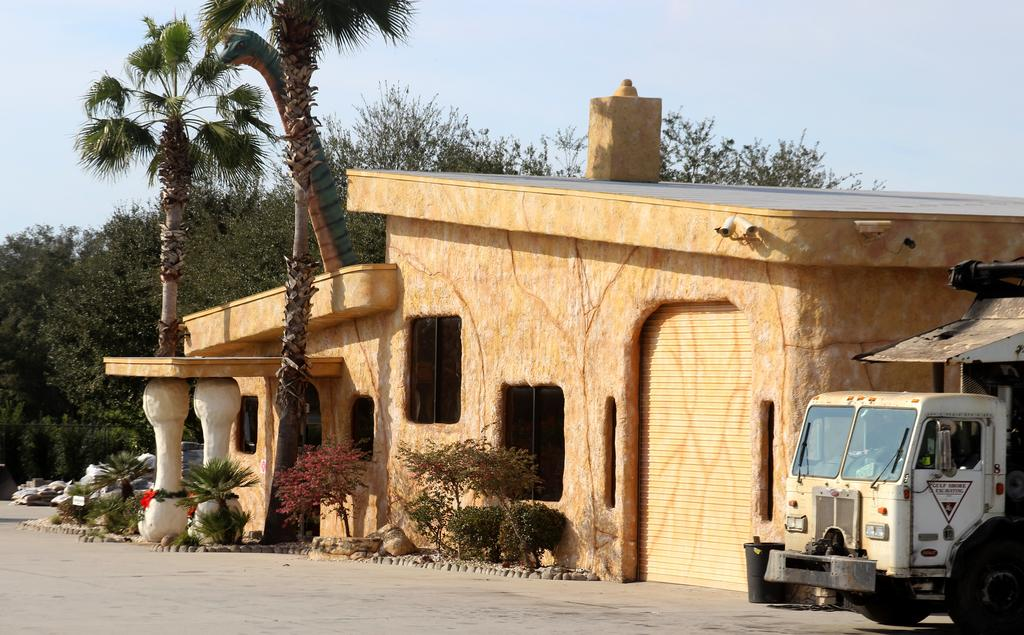What type of structure is depicted in the image? There is an architecture in the image. What is located beside the architecture? There is a vehicle beside the architecture. What type of vegetation is present around the architecture? There are plants and trees around the architecture. How many jellyfish can be seen swimming around the architecture in the image? There are no jellyfish present in the image; it features an architecture with a vehicle, plants, and trees. 